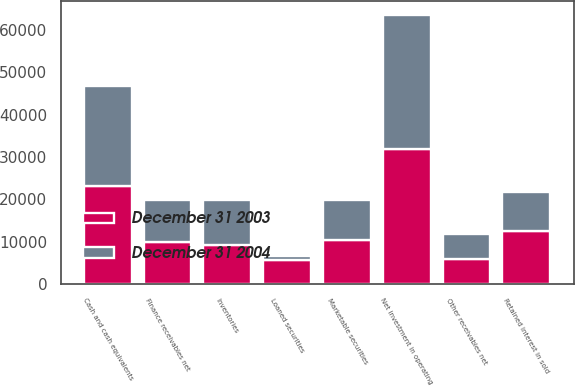Convert chart. <chart><loc_0><loc_0><loc_500><loc_500><stacked_bar_chart><ecel><fcel>Cash and cash equivalents<fcel>Marketable securities<fcel>Loaned securities<fcel>Finance receivables net<fcel>Other receivables net<fcel>Net investment in operating<fcel>Retained interest in sold<fcel>Inventories<nl><fcel>December 31 2004<fcel>23511<fcel>9507<fcel>1058<fcel>9973<fcel>5971<fcel>31763<fcel>9166<fcel>10766<nl><fcel>December 31 2003<fcel>23208<fcel>10439<fcel>5667<fcel>9973<fcel>5851<fcel>31859<fcel>12569<fcel>9151<nl></chart> 